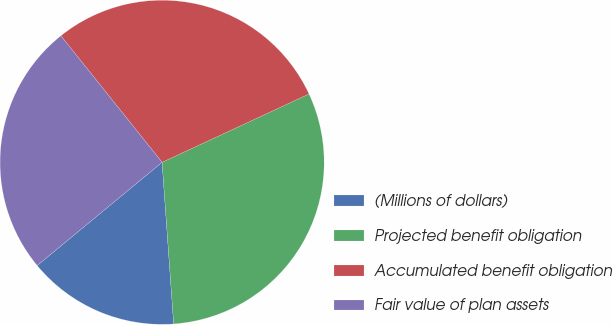Convert chart. <chart><loc_0><loc_0><loc_500><loc_500><pie_chart><fcel>(Millions of dollars)<fcel>Projected benefit obligation<fcel>Accumulated benefit obligation<fcel>Fair value of plan assets<nl><fcel>15.15%<fcel>30.79%<fcel>28.81%<fcel>25.25%<nl></chart> 